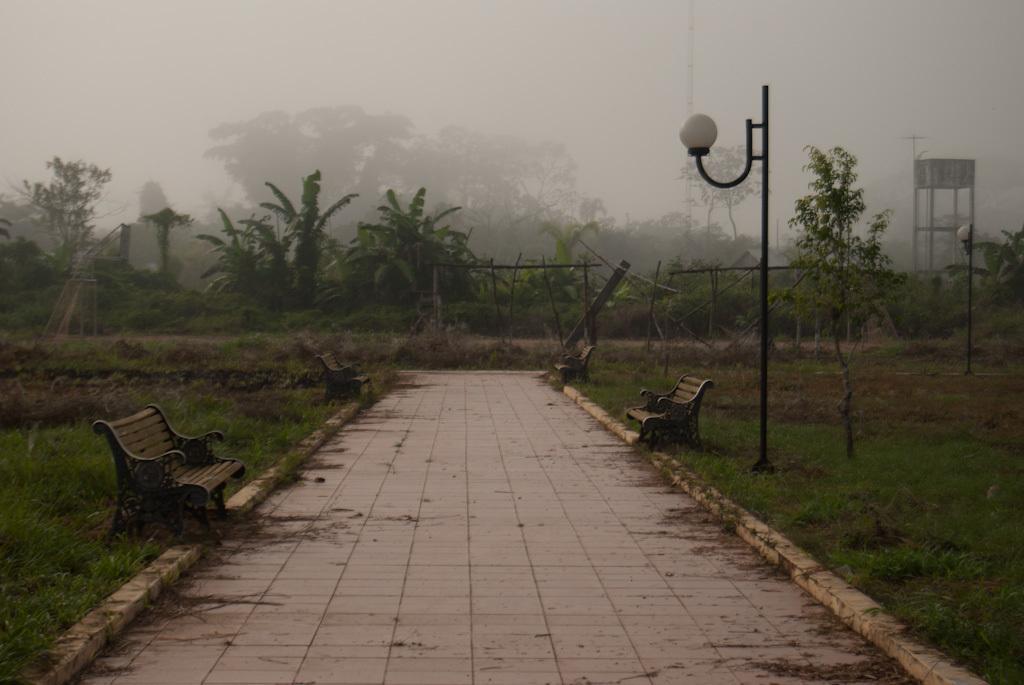Please provide a concise description of this image. In this image we can see a pathway and some benches beside it. We can also see some grass, a street pole, a group of trees, fence and the sky which looks cloudy. 